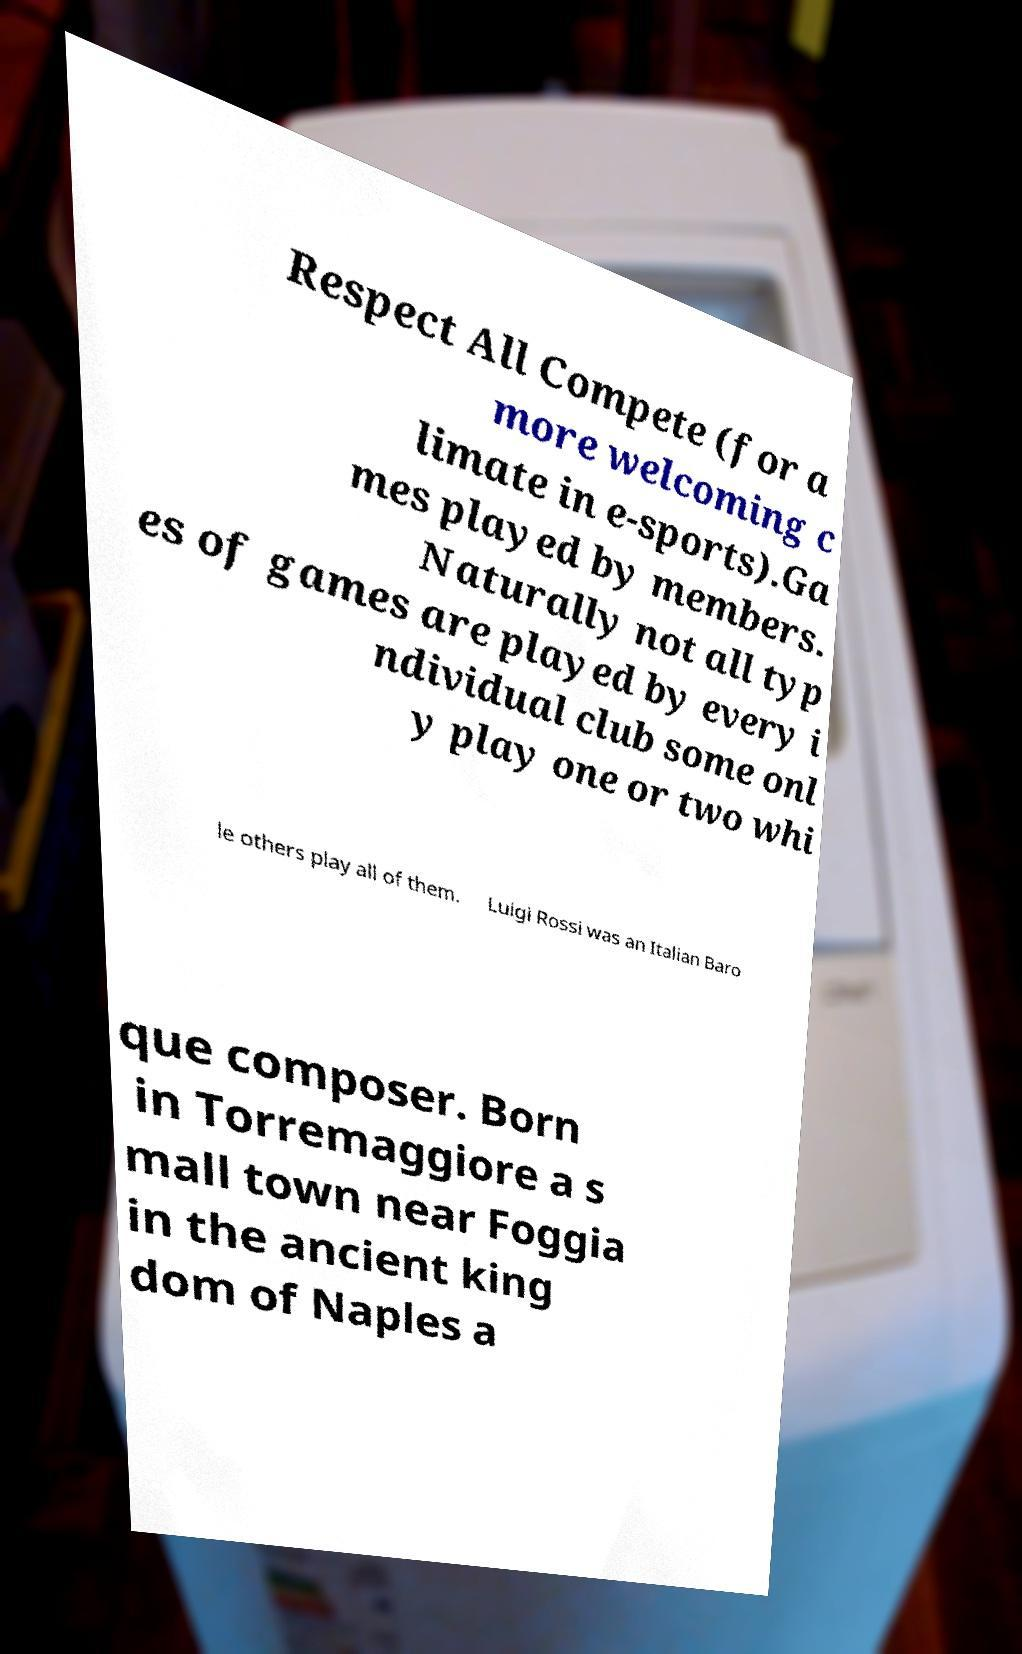Could you assist in decoding the text presented in this image and type it out clearly? Respect All Compete (for a more welcoming c limate in e-sports).Ga mes played by members. Naturally not all typ es of games are played by every i ndividual club some onl y play one or two whi le others play all of them. Luigi Rossi was an Italian Baro que composer. Born in Torremaggiore a s mall town near Foggia in the ancient king dom of Naples a 